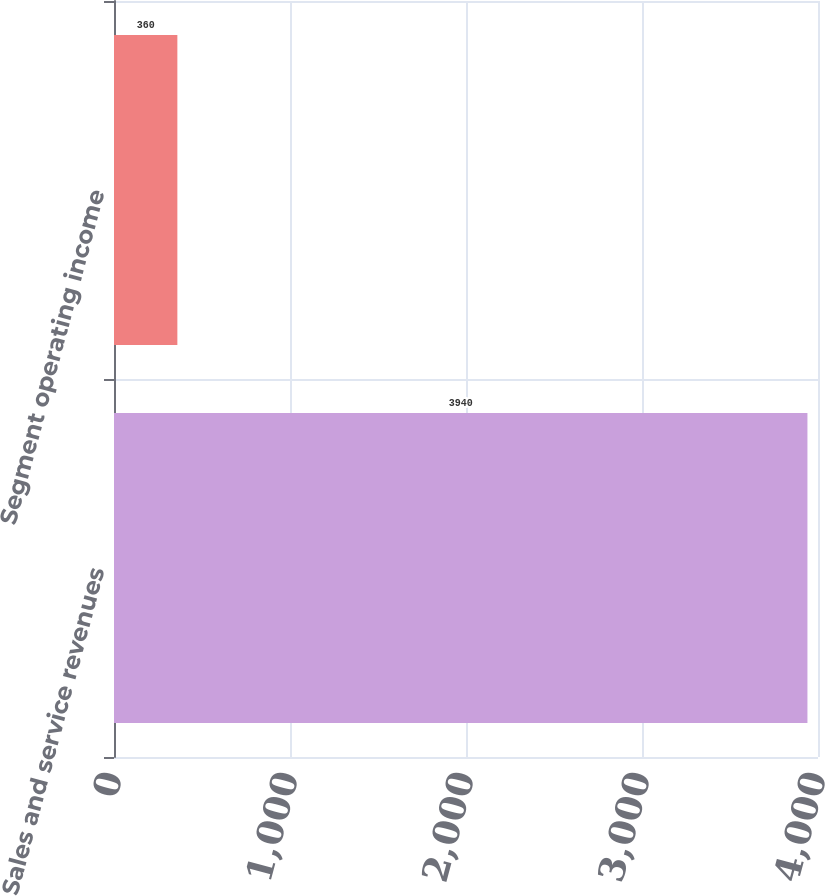<chart> <loc_0><loc_0><loc_500><loc_500><bar_chart><fcel>Sales and service revenues<fcel>Segment operating income<nl><fcel>3940<fcel>360<nl></chart> 